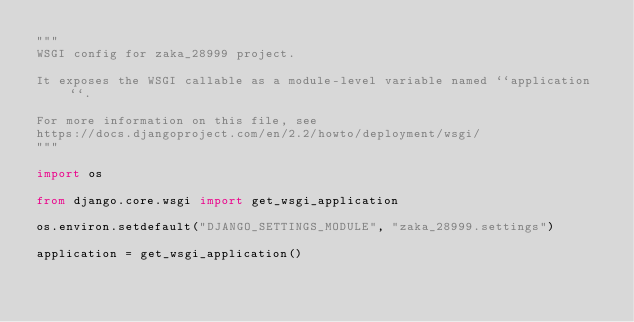<code> <loc_0><loc_0><loc_500><loc_500><_Python_>"""
WSGI config for zaka_28999 project.

It exposes the WSGI callable as a module-level variable named ``application``.

For more information on this file, see
https://docs.djangoproject.com/en/2.2/howto/deployment/wsgi/
"""

import os

from django.core.wsgi import get_wsgi_application

os.environ.setdefault("DJANGO_SETTINGS_MODULE", "zaka_28999.settings")

application = get_wsgi_application()
</code> 